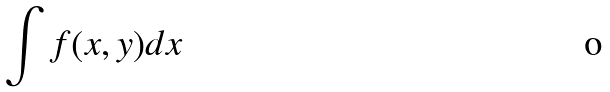<formula> <loc_0><loc_0><loc_500><loc_500>\int f ( x , y ) d x</formula> 